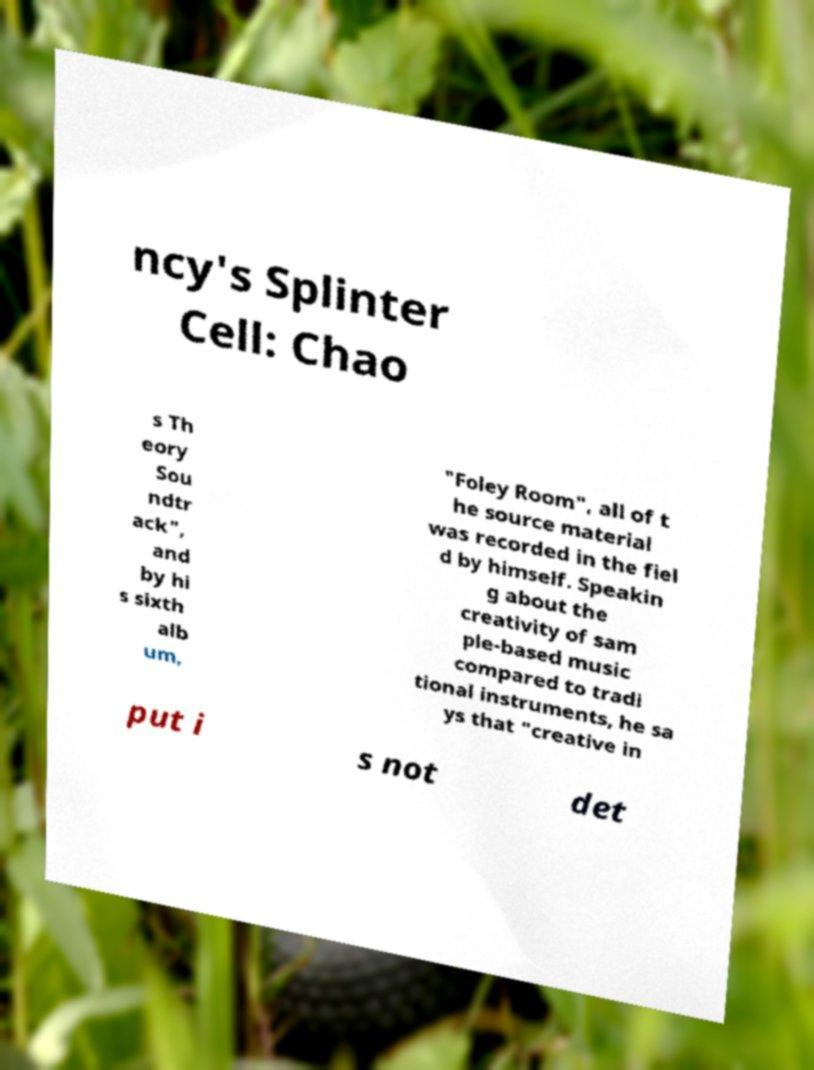I need the written content from this picture converted into text. Can you do that? ncy's Splinter Cell: Chao s Th eory Sou ndtr ack", and by hi s sixth alb um, "Foley Room", all of t he source material was recorded in the fiel d by himself. Speakin g about the creativity of sam ple-based music compared to tradi tional instruments, he sa ys that "creative in put i s not det 